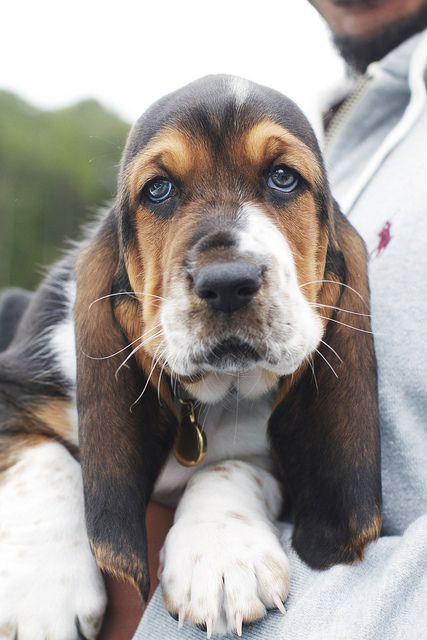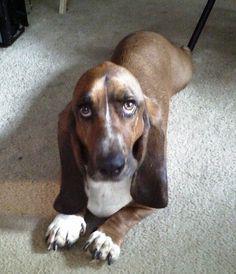The first image is the image on the left, the second image is the image on the right. Assess this claim about the two images: "Each image shows exactly one dog, which is a long-eared hound.". Correct or not? Answer yes or no. Yes. 